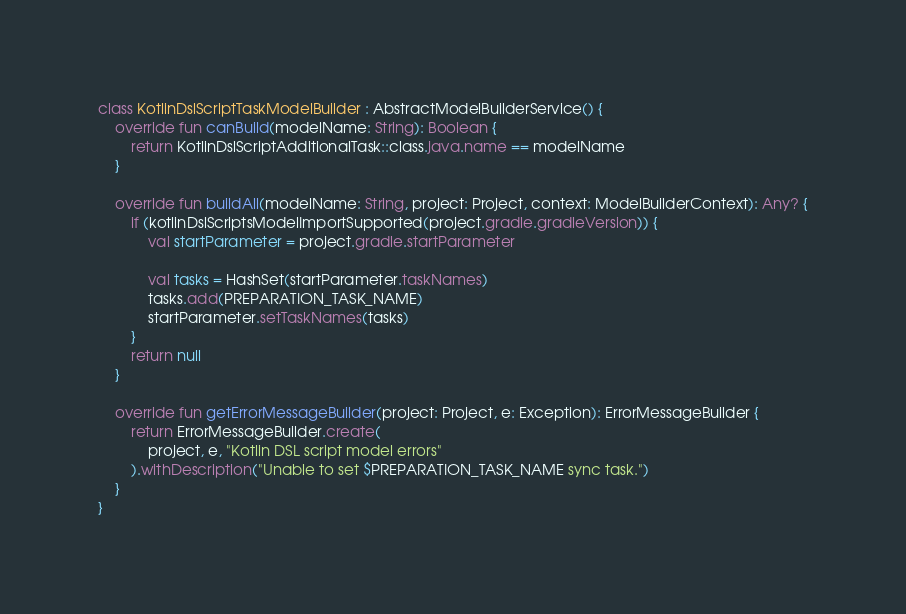Convert code to text. <code><loc_0><loc_0><loc_500><loc_500><_Kotlin_>class KotlinDslScriptTaskModelBuilder : AbstractModelBuilderService() {
    override fun canBuild(modelName: String): Boolean {
        return KotlinDslScriptAdditionalTask::class.java.name == modelName
    }

    override fun buildAll(modelName: String, project: Project, context: ModelBuilderContext): Any? {
        if (kotlinDslScriptsModelImportSupported(project.gradle.gradleVersion)) {
            val startParameter = project.gradle.startParameter

            val tasks = HashSet(startParameter.taskNames)
            tasks.add(PREPARATION_TASK_NAME)
            startParameter.setTaskNames(tasks)
        }
        return null
    }

    override fun getErrorMessageBuilder(project: Project, e: Exception): ErrorMessageBuilder {
        return ErrorMessageBuilder.create(
            project, e, "Kotlin DSL script model errors"
        ).withDescription("Unable to set $PREPARATION_TASK_NAME sync task.")
    }
}</code> 